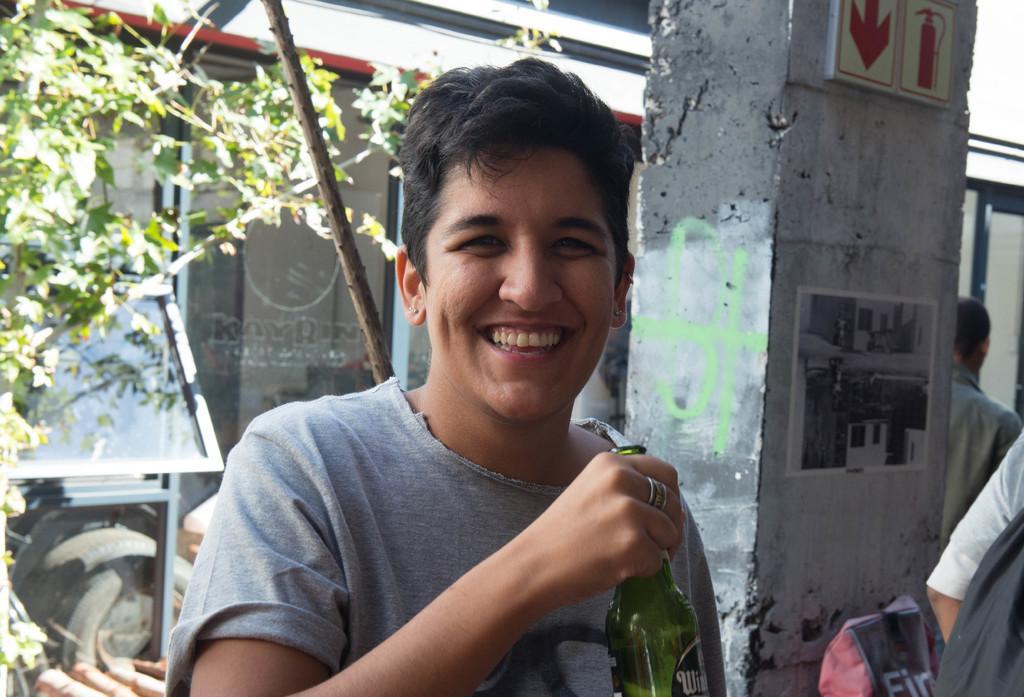How would you summarize this image in a sentence or two? A woman is posing to camera with a beer bottle in her hand. There is pillar in the background. Few men are standing aside. 